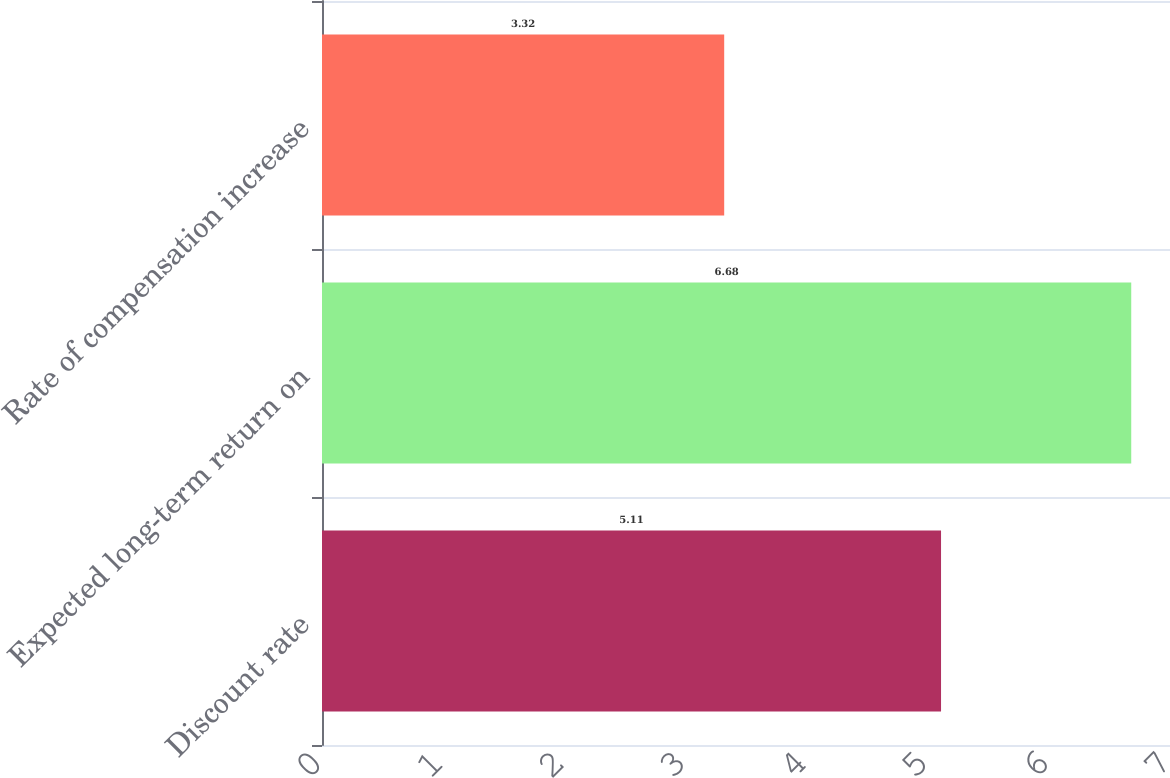<chart> <loc_0><loc_0><loc_500><loc_500><bar_chart><fcel>Discount rate<fcel>Expected long-term return on<fcel>Rate of compensation increase<nl><fcel>5.11<fcel>6.68<fcel>3.32<nl></chart> 